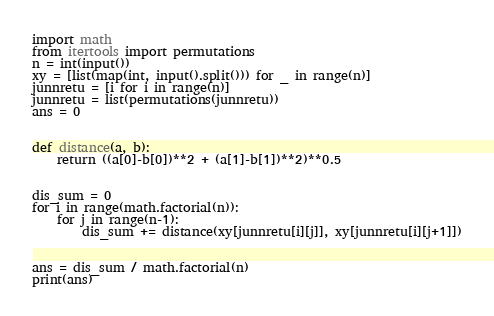Convert code to text. <code><loc_0><loc_0><loc_500><loc_500><_Python_>import math
from itertools import permutations
n = int(input())
xy = [list(map(int, input().split())) for _ in range(n)]
junnretu = [i for i in range(n)]
junnretu = list(permutations(junnretu))
ans = 0


def distance(a, b):
    return ((a[0]-b[0])**2 + (a[1]-b[1])**2)**0.5


dis_sum = 0
for i in range(math.factorial(n)):
    for j in range(n-1):
        dis_sum += distance(xy[junnretu[i][j]], xy[junnretu[i][j+1]])


ans = dis_sum / math.factorial(n)
print(ans)</code> 